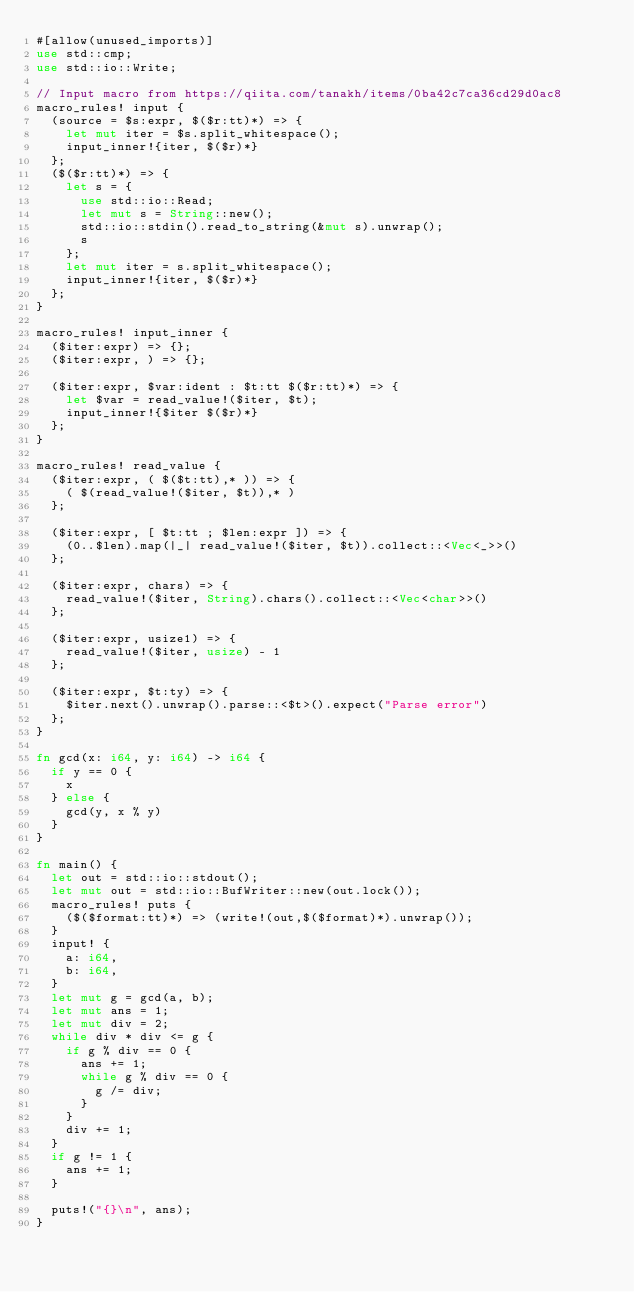<code> <loc_0><loc_0><loc_500><loc_500><_Rust_>#[allow(unused_imports)]
use std::cmp;
use std::io::Write;

// Input macro from https://qiita.com/tanakh/items/0ba42c7ca36cd29d0ac8
macro_rules! input {
  (source = $s:expr, $($r:tt)*) => {
    let mut iter = $s.split_whitespace();
    input_inner!{iter, $($r)*}
  };
  ($($r:tt)*) => {
    let s = {
      use std::io::Read;
      let mut s = String::new();
      std::io::stdin().read_to_string(&mut s).unwrap();
      s
    };
    let mut iter = s.split_whitespace();
    input_inner!{iter, $($r)*}
  };
}

macro_rules! input_inner {
  ($iter:expr) => {};
  ($iter:expr, ) => {};

  ($iter:expr, $var:ident : $t:tt $($r:tt)*) => {
    let $var = read_value!($iter, $t);
    input_inner!{$iter $($r)*}
  };
}

macro_rules! read_value {
  ($iter:expr, ( $($t:tt),* )) => {
    ( $(read_value!($iter, $t)),* )
  };

  ($iter:expr, [ $t:tt ; $len:expr ]) => {
    (0..$len).map(|_| read_value!($iter, $t)).collect::<Vec<_>>()
  };

  ($iter:expr, chars) => {
    read_value!($iter, String).chars().collect::<Vec<char>>()
  };

  ($iter:expr, usize1) => {
    read_value!($iter, usize) - 1
  };

  ($iter:expr, $t:ty) => {
    $iter.next().unwrap().parse::<$t>().expect("Parse error")
  };
}

fn gcd(x: i64, y: i64) -> i64 {
  if y == 0 {
    x
  } else {
    gcd(y, x % y)
  }
}

fn main() {
  let out = std::io::stdout();
  let mut out = std::io::BufWriter::new(out.lock());
  macro_rules! puts {
    ($($format:tt)*) => (write!(out,$($format)*).unwrap());
  }
  input! {
    a: i64,
    b: i64,
  }
  let mut g = gcd(a, b);
  let mut ans = 1;
  let mut div = 2;
  while div * div <= g {
    if g % div == 0 {
      ans += 1;
      while g % div == 0 {
        g /= div;
      }
    }
    div += 1;
  }
  if g != 1 {
    ans += 1;
  }

  puts!("{}\n", ans);
}
</code> 